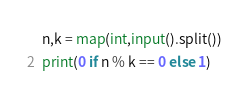<code> <loc_0><loc_0><loc_500><loc_500><_Python_>n,k = map(int,input().split())
print(0 if n % k == 0 else 1)</code> 